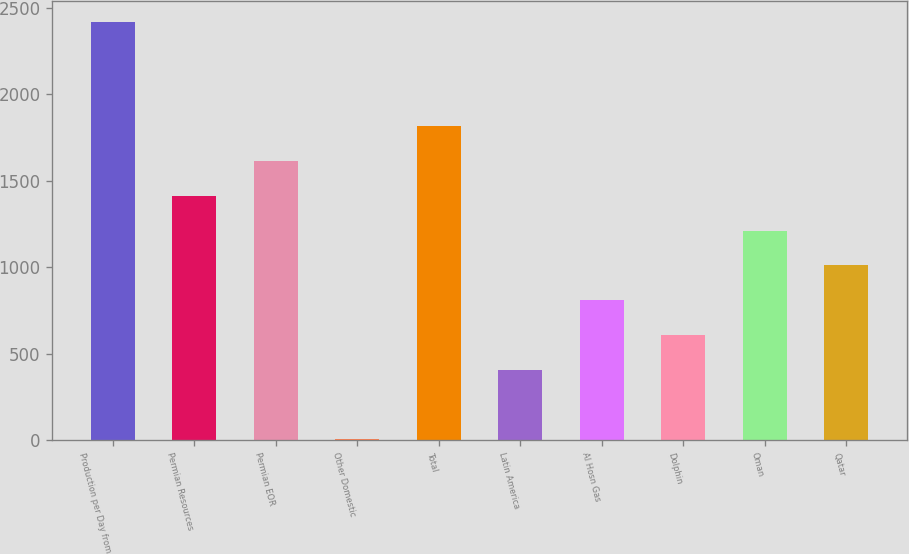Convert chart to OTSL. <chart><loc_0><loc_0><loc_500><loc_500><bar_chart><fcel>Production per Day from<fcel>Permian Resources<fcel>Permian EOR<fcel>Other Domestic<fcel>Total<fcel>Latin America<fcel>Al Hosn Gas<fcel>Dolphin<fcel>Oman<fcel>Qatar<nl><fcel>2418.4<fcel>1412.4<fcel>1613.6<fcel>4<fcel>1814.8<fcel>406.4<fcel>808.8<fcel>607.6<fcel>1211.2<fcel>1010<nl></chart> 